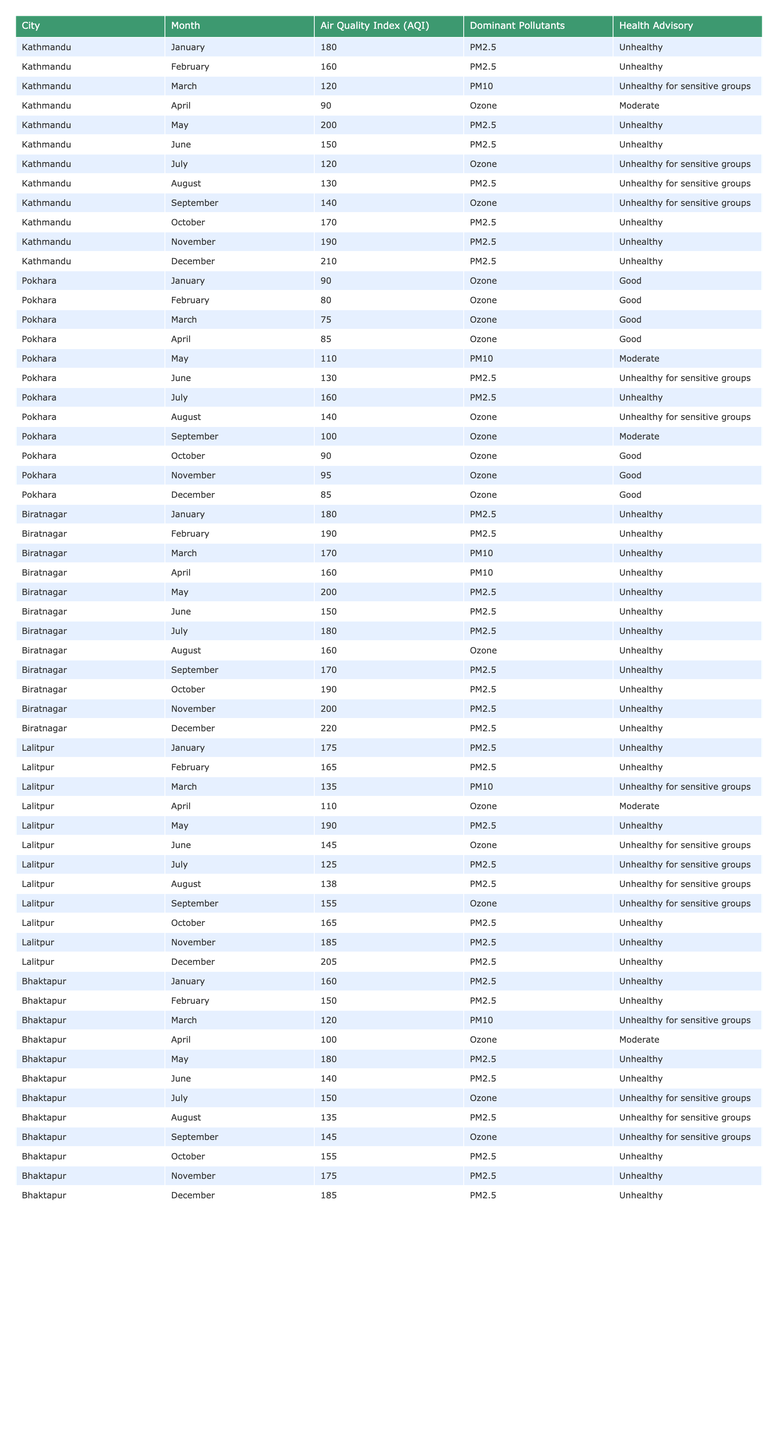What is the Air Quality Index (AQI) for Kathmandu in December? The AQI for Kathmandu in December is directly retrieved from the table, which states it is 210.
Answer: 210 Which city had the best air quality in January? In January, Pokhara had an AQI of 90, while other cities (Kathmandu, Biratnagar, Lalitpur, and Bhaktapur) had higher AQI values of 180, 180, 175, and 160 respectively. Hence, Pokhara had the best air quality.
Answer: Pokhara What is the dominant pollutant in Pokhara during June? According to the table, the dominant pollutant in Pokhara during June is PM2.5 as listed for that month.
Answer: PM2.5 Which month had the highest AQI in Biratnagar? The highest AQI in Biratnagar is 220, recorded in December, as seen in the table.
Answer: December What is the average AQI for Lalitpur across the months listed? To find the average: (175 + 165 + 135 + 110 + 190 + 145 + 125 + 138 + 155 + 165 + 185 + 205) = 1,840; there are 12 months, so the average AQI is 1,840/12 = 153.33.
Answer: 153.33 How many months are there when air quality was categorized as "Unhealthy" for sensitive groups in Bhaktapur? From the table, the months categorized as "Unhealthy for sensitive groups" are March, July, August, and September which totals to 4 months.
Answer: 4 Did any city report an AQI of less than 100 in the months listed? Yes, Pokhara reported an AQI less than 100 in January (90), February (80), March (75), April (85), October (90), November (95), and December (85), which confirms this statement as true.
Answer: Yes What is the trend in air quality for Kathmandu from January to December? The AQI shows a general increasing trend, starting at 180 in January and ending at 210 in December, indicating worsening air quality over the year.
Answer: Worsening Is there any month where both Pokhara and Kathmandu reported an AQI categorized as "Good"? By examining the table, Pokhara shows "Good" for January, February, March, April, October, November, and December whereas Kathmandu never showed "Good." Thus, the answer is no.
Answer: No What was the dominant pollutant in Biratnagar during March, and how does it compare to the same month in Kathmandu? In Biratnagar, the dominant pollutant in March is PM10, while in Kathmandu it is PM10 as well. However, the AQI for Biratnagar is 170 (Unhealthy), compared to 120 in Kathmandu (Unhealthy for sensitive groups).
Answer: PM10; Biratnagar is worse 